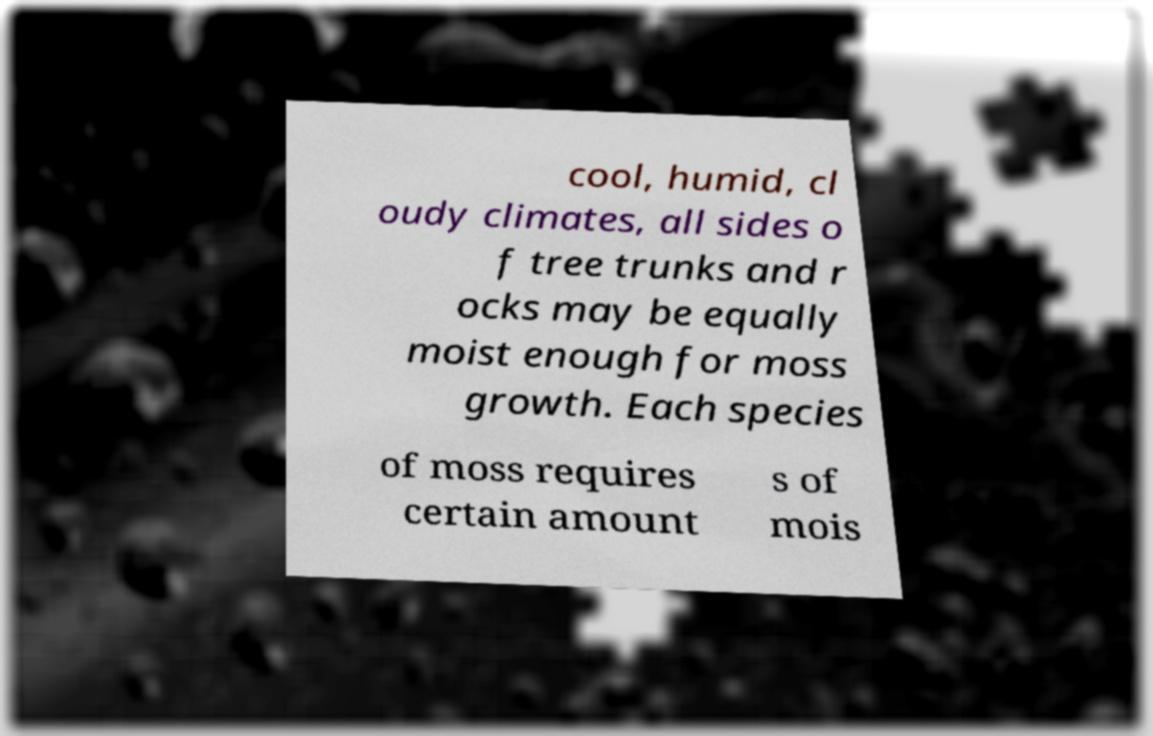Can you accurately transcribe the text from the provided image for me? cool, humid, cl oudy climates, all sides o f tree trunks and r ocks may be equally moist enough for moss growth. Each species of moss requires certain amount s of mois 